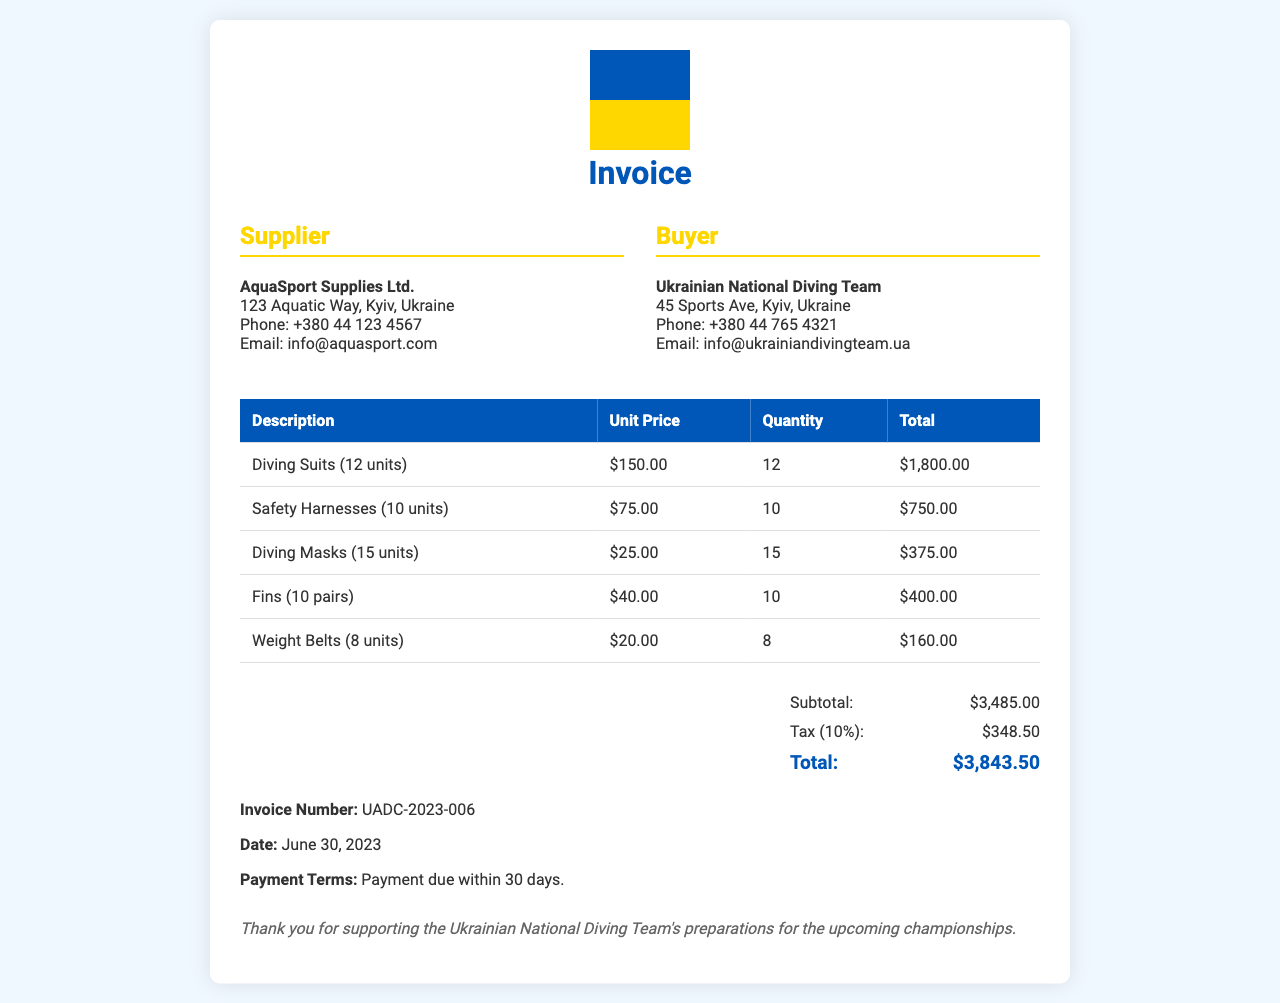What is the invoice number? The invoice number is indicated at the bottom of the document as "Invoice Number: UADC-2023-006."
Answer: UADC-2023-006 Who is the supplier? The supplier's name is provided in the "Supplier" section, which states "AquaSport Supplies Ltd."
Answer: AquaSport Supplies Ltd What is the total amount due? The total amount due is detailed in the summary section as "Total: $3,843.50."
Answer: $3,843.50 How many diving suits were purchased? The document states "Diving Suits (12 units)," indicating the quantity purchased.
Answer: 12 units What is the tax percentage applied? The tax percentage is specified as "Tax (10%):" in the summary section.
Answer: 10% Who is the buyer? The buyer is identified in the "Buyer" section as "Ukrainian National Diving Team."
Answer: Ukrainian National Diving Team What is the due date for payment? The payment terms specify "Payment due within 30 days," which implies a general timeline for when payment should be made.
Answer: 30 days What is the subtotal before tax? The subtotal before tax is shown as "Subtotal: $3,485.00" in the summary section.
Answer: $3,485.00 How many pairs of fins were acquired? The document states "Fins (10 pairs)," which indicates the quantity of fins purchased.
Answer: 10 pairs 